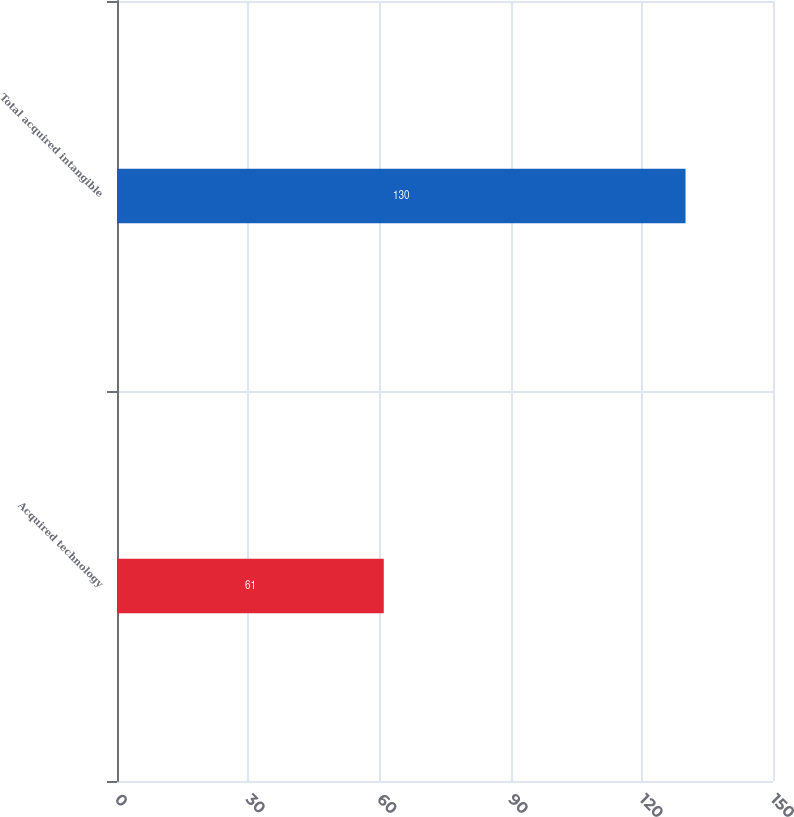Convert chart. <chart><loc_0><loc_0><loc_500><loc_500><bar_chart><fcel>Acquired technology<fcel>Total acquired intangible<nl><fcel>61<fcel>130<nl></chart> 